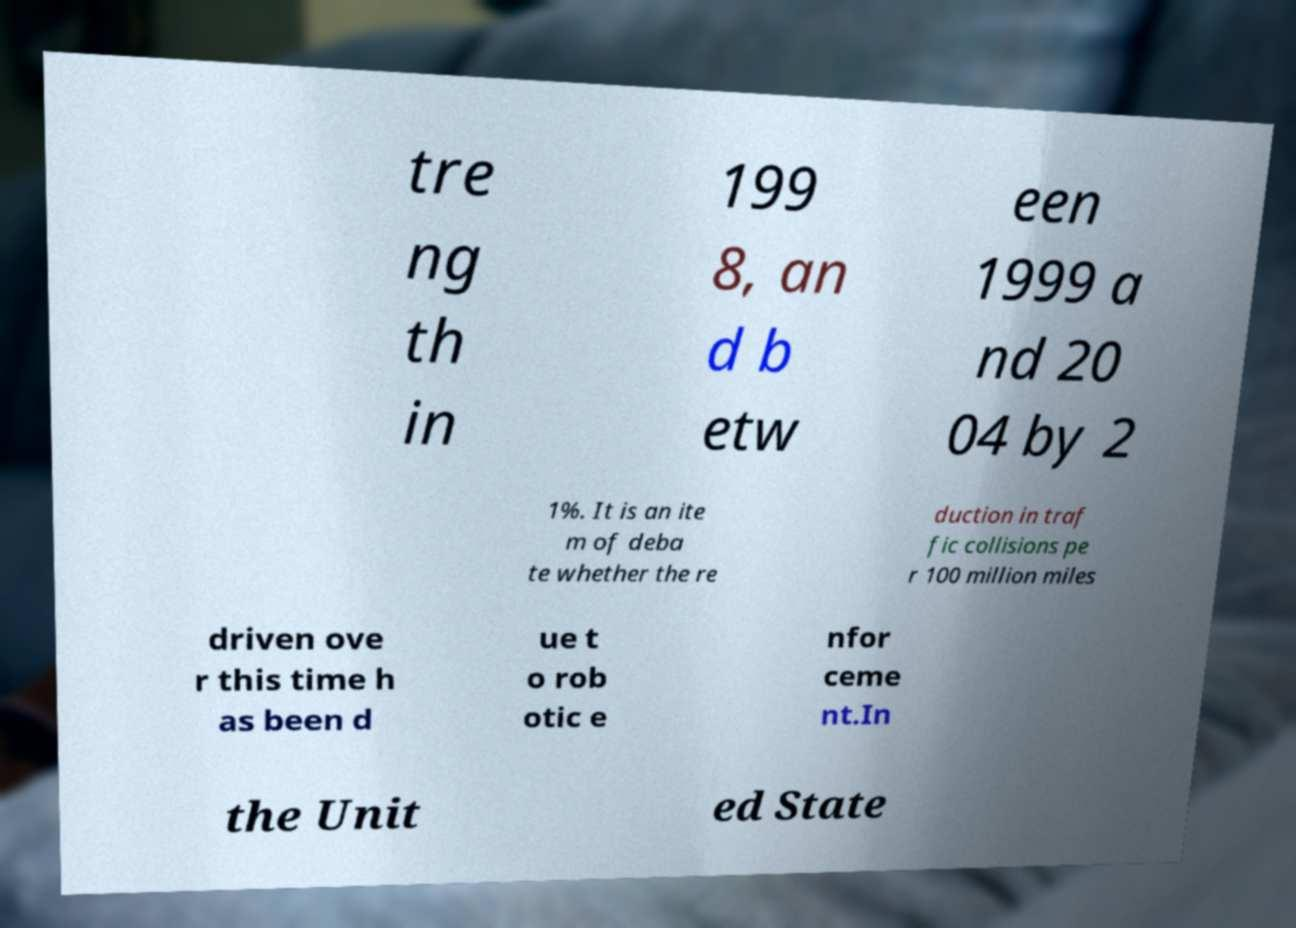For documentation purposes, I need the text within this image transcribed. Could you provide that? tre ng th in 199 8, an d b etw een 1999 a nd 20 04 by 2 1%. It is an ite m of deba te whether the re duction in traf fic collisions pe r 100 million miles driven ove r this time h as been d ue t o rob otic e nfor ceme nt.In the Unit ed State 